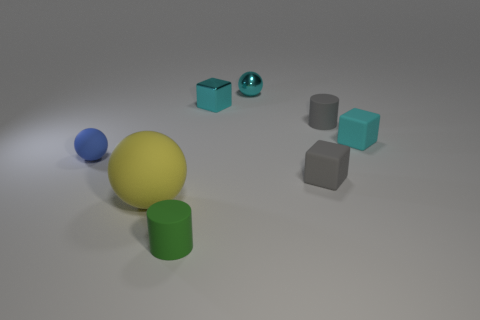What kind of lighting or atmosphere do you think this image conveys? The image projects a soft and diffused lighting atmosphere, likely from an overhead source. The shadows are gentle and extend diagonally across the floor, indicating the light source is above and slightly to one side. The subtle gradients on the surfaces of the objects suggest a calm, controlled environment, possibly indicative of a studio-like setting designed to highlight the forms and textures of the objects without harsh contrasts. 